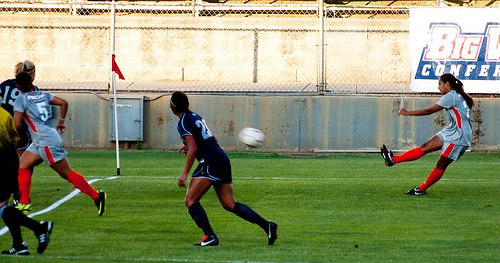<image>
Can you confirm if the ball is on the grass? No. The ball is not positioned on the grass. They may be near each other, but the ball is not supported by or resting on top of the grass. 